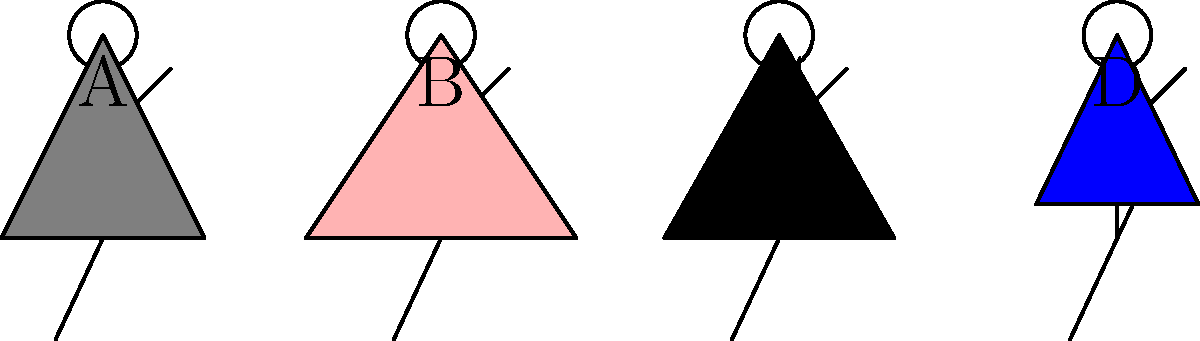Based on the stick figure illustrations above, which outfit combination would be most appropriate for a shy high school student to wear to prom? To determine the most appropriate outfit for a shy high school student attending prom, let's analyze each option:

1. Option A: Suit
   - A suit is a formal option that is generally appropriate for prom.
   - It's a classic choice that can help boost confidence for a shy student.
   - Suits are versatile and can be styled to fit various comfort levels.

2. Option B: Dress
   - While dresses are common for prom, they might not be the preferred choice for all students, especially those who are shy or less comfortable in traditionally feminine attire.

3. Option C: Tuxedo
   - A tuxedo is the most formal option presented.
   - It might be considered too formal for some high school proms, potentially making a shy student feel overdressed or uncomfortable.

4. Option D: Casual outfit
   - Casual attire is typically not appropriate for prom, which is generally a formal or semi-formal event.
   - Wearing casual clothes might make a shy student feel out of place among more formally dressed peers.

Considering the persona of a shy high school student, the most appropriate choice would be Option A: the suit. Here's why:

1. Formality: It meets the formal requirements of prom without being overly formal like a tuxedo.
2. Comfort: Suits can be adjusted for comfort, which is important for a shy person.
3. Versatility: The suit can be styled in various ways to match the student's personal style and comfort level.
4. Confidence: Wearing a well-fitted suit can boost confidence, which is beneficial for a shy student.

The suit provides a balance between looking appropriate for the occasion and feeling comfortable, which is crucial for a shy student attending prom.
Answer: Option A: Suit 